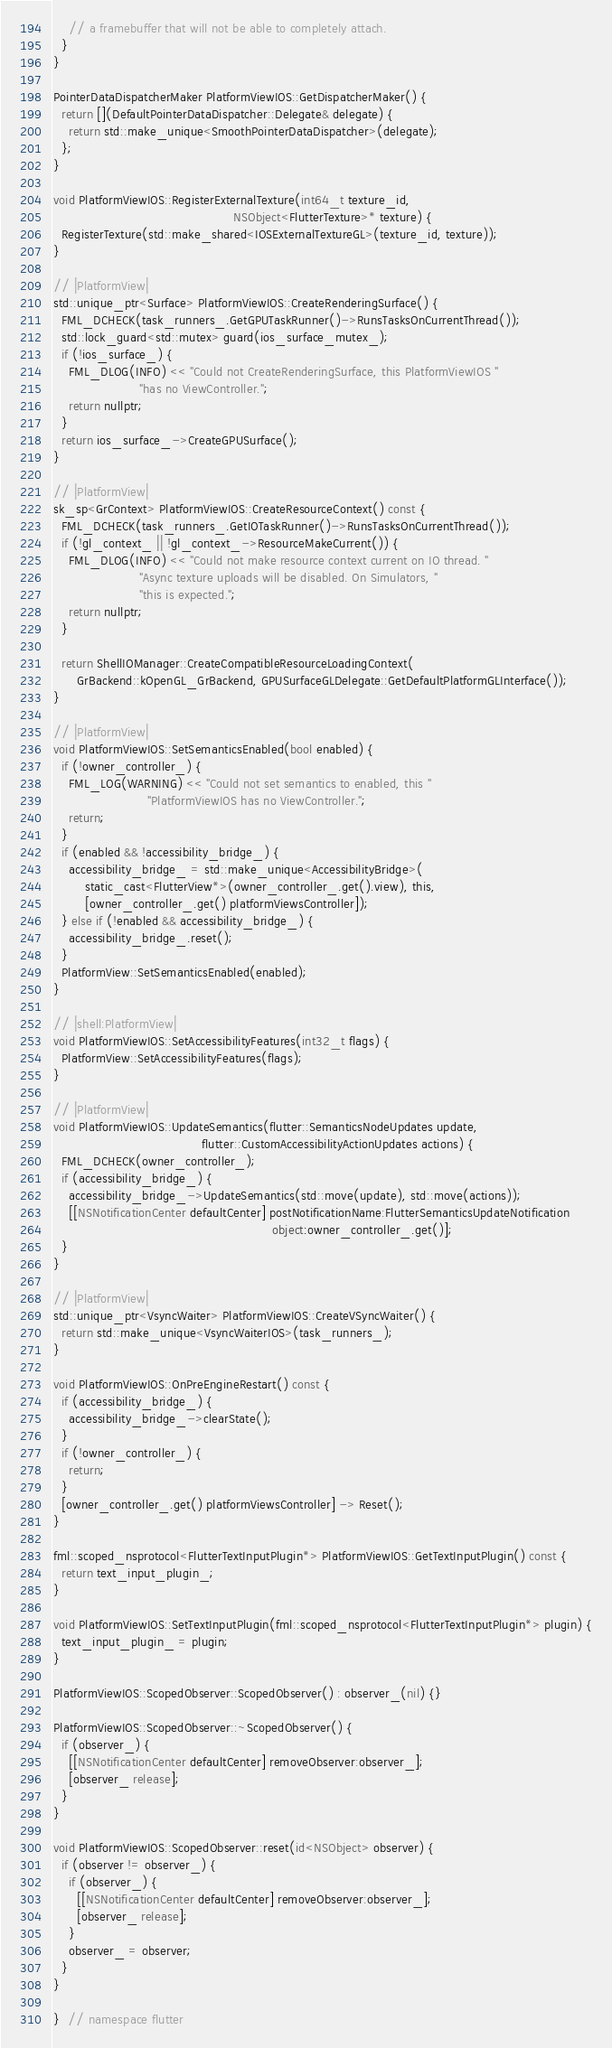<code> <loc_0><loc_0><loc_500><loc_500><_ObjectiveC_>    // a framebuffer that will not be able to completely attach.
  }
}

PointerDataDispatcherMaker PlatformViewIOS::GetDispatcherMaker() {
  return [](DefaultPointerDataDispatcher::Delegate& delegate) {
    return std::make_unique<SmoothPointerDataDispatcher>(delegate);
  };
}

void PlatformViewIOS::RegisterExternalTexture(int64_t texture_id,
                                              NSObject<FlutterTexture>* texture) {
  RegisterTexture(std::make_shared<IOSExternalTextureGL>(texture_id, texture));
}

// |PlatformView|
std::unique_ptr<Surface> PlatformViewIOS::CreateRenderingSurface() {
  FML_DCHECK(task_runners_.GetGPUTaskRunner()->RunsTasksOnCurrentThread());
  std::lock_guard<std::mutex> guard(ios_surface_mutex_);
  if (!ios_surface_) {
    FML_DLOG(INFO) << "Could not CreateRenderingSurface, this PlatformViewIOS "
                      "has no ViewController.";
    return nullptr;
  }
  return ios_surface_->CreateGPUSurface();
}

// |PlatformView|
sk_sp<GrContext> PlatformViewIOS::CreateResourceContext() const {
  FML_DCHECK(task_runners_.GetIOTaskRunner()->RunsTasksOnCurrentThread());
  if (!gl_context_ || !gl_context_->ResourceMakeCurrent()) {
    FML_DLOG(INFO) << "Could not make resource context current on IO thread. "
                      "Async texture uploads will be disabled. On Simulators, "
                      "this is expected.";
    return nullptr;
  }

  return ShellIOManager::CreateCompatibleResourceLoadingContext(
      GrBackend::kOpenGL_GrBackend, GPUSurfaceGLDelegate::GetDefaultPlatformGLInterface());
}

// |PlatformView|
void PlatformViewIOS::SetSemanticsEnabled(bool enabled) {
  if (!owner_controller_) {
    FML_LOG(WARNING) << "Could not set semantics to enabled, this "
                        "PlatformViewIOS has no ViewController.";
    return;
  }
  if (enabled && !accessibility_bridge_) {
    accessibility_bridge_ = std::make_unique<AccessibilityBridge>(
        static_cast<FlutterView*>(owner_controller_.get().view), this,
        [owner_controller_.get() platformViewsController]);
  } else if (!enabled && accessibility_bridge_) {
    accessibility_bridge_.reset();
  }
  PlatformView::SetSemanticsEnabled(enabled);
}

// |shell:PlatformView|
void PlatformViewIOS::SetAccessibilityFeatures(int32_t flags) {
  PlatformView::SetAccessibilityFeatures(flags);
}

// |PlatformView|
void PlatformViewIOS::UpdateSemantics(flutter::SemanticsNodeUpdates update,
                                      flutter::CustomAccessibilityActionUpdates actions) {
  FML_DCHECK(owner_controller_);
  if (accessibility_bridge_) {
    accessibility_bridge_->UpdateSemantics(std::move(update), std::move(actions));
    [[NSNotificationCenter defaultCenter] postNotificationName:FlutterSemanticsUpdateNotification
                                                        object:owner_controller_.get()];
  }
}

// |PlatformView|
std::unique_ptr<VsyncWaiter> PlatformViewIOS::CreateVSyncWaiter() {
  return std::make_unique<VsyncWaiterIOS>(task_runners_);
}

void PlatformViewIOS::OnPreEngineRestart() const {
  if (accessibility_bridge_) {
    accessibility_bridge_->clearState();
  }
  if (!owner_controller_) {
    return;
  }
  [owner_controller_.get() platformViewsController] -> Reset();
}

fml::scoped_nsprotocol<FlutterTextInputPlugin*> PlatformViewIOS::GetTextInputPlugin() const {
  return text_input_plugin_;
}

void PlatformViewIOS::SetTextInputPlugin(fml::scoped_nsprotocol<FlutterTextInputPlugin*> plugin) {
  text_input_plugin_ = plugin;
}

PlatformViewIOS::ScopedObserver::ScopedObserver() : observer_(nil) {}

PlatformViewIOS::ScopedObserver::~ScopedObserver() {
  if (observer_) {
    [[NSNotificationCenter defaultCenter] removeObserver:observer_];
    [observer_ release];
  }
}

void PlatformViewIOS::ScopedObserver::reset(id<NSObject> observer) {
  if (observer != observer_) {
    if (observer_) {
      [[NSNotificationCenter defaultCenter] removeObserver:observer_];
      [observer_ release];
    }
    observer_ = observer;
  }
}

}  // namespace flutter
</code> 